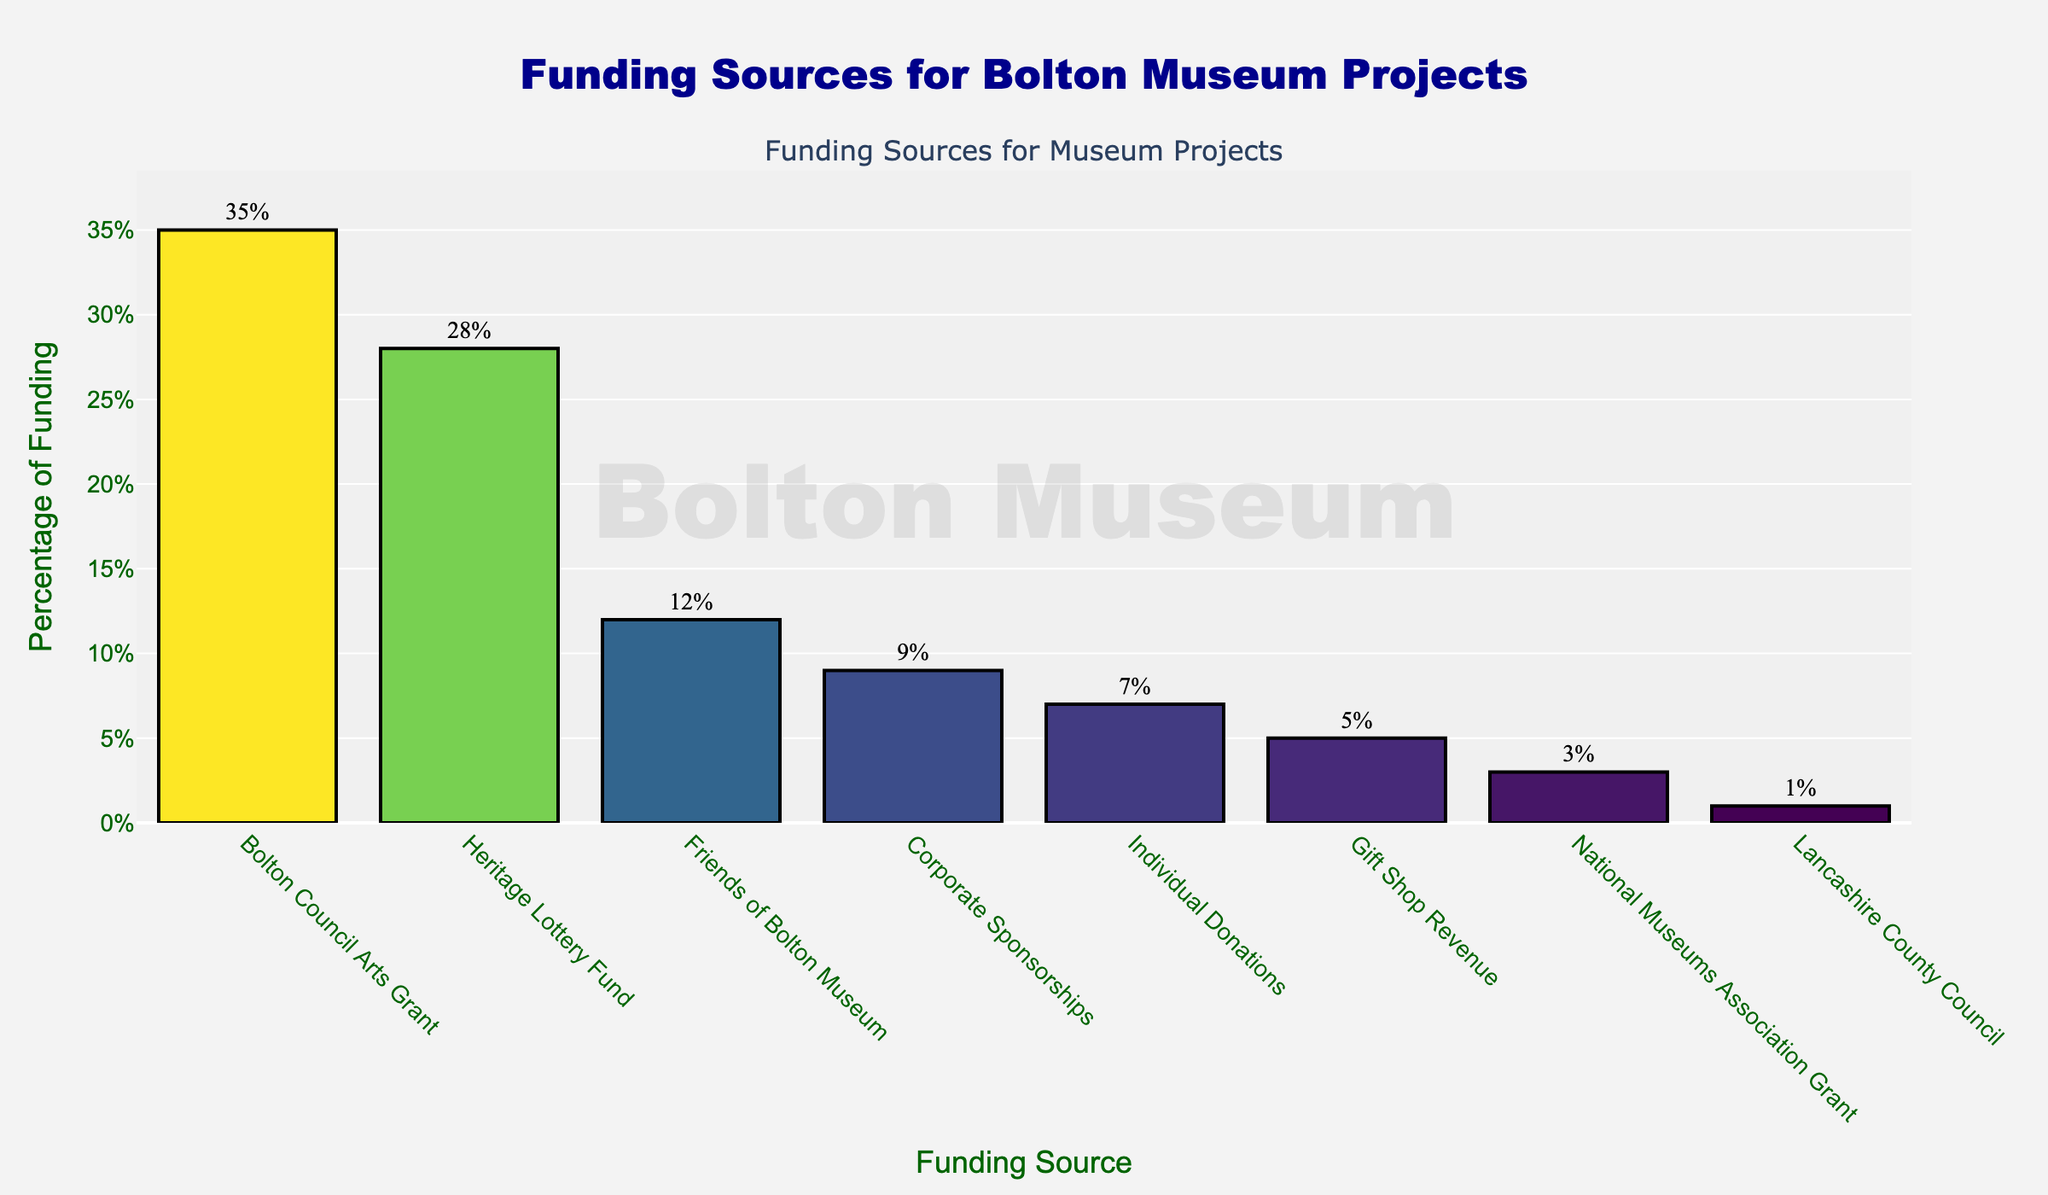Which funding source contributes the highest percentage? The bar for "Bolton Council Arts Grant" is the tallest at 35%.
Answer: Bolton Council Arts Grant Which funding source has the lowest contribution percentage? The shortest bar is for "Lancashire County Council," contributing 1%.
Answer: Lancashire County Council What is the combined percentage of funding from "Heritage Lottery Fund" and "Friends of Bolton Museum"? The bar for "Heritage Lottery Fund" is 28%, and the bar for "Friends of Bolton Museum" is 12%. Their combined percentage is 28% + 12% = 40%.
Answer: 40% How much greater is the percentage contribution of "Corporate Sponsorships" compared to "Gift Shop Revenue"? The bar for "Corporate Sponsorships" is 9%, and the bar for "Gift Shop Revenue" is 5%. The difference is 9% - 5% = 4%.
Answer: 4% Which funding source ranks third in terms of percentage contribution? The third tallest bar corresponds to "Friends of Bolton Museum" with a contribution of 12%.
Answer: Friends of Bolton Museum Are there any funding sources with the same contribution percentage? No bars have the same height or value, indicating no matching percentages.
Answer: No What is the total percentage of funding contributed by "Corporate Sponsorships," "Individual Donations," and "Gift Shop Revenue"? The bars indicate "Corporate Sponsorships" at 9%, "Individual Donations" at 7%, and "Gift Shop Revenue" at 5%. Their total is 9% + 7% + 5% = 21%.
Answer: 21% Which funding source's bar color is the darkest shade? The bars' shading corresponds to their funding percentages; the bar for "Bolton Council Arts Grant" is the darkest since it's the highest percentage at 35%.
Answer: Bolton Council Arts Grant By how much does the percentage contribution of "Heritage Lottery Fund" exceed that of "National Museums Association Grant"? The bar for "Heritage Lottery Fund" is 28%, and for "National Museums Association Grant" it is 3%. The difference is 28% - 3% = 25%.
Answer: 25% What is the average percentage contribution of all the funding sources? Summing all percentages: 35 + 28 + 12 + 9 + 7 + 5 + 3 + 1 = 100. There are 8 sources, so the average is 100 / 8 = 12.5.
Answer: 12.5 